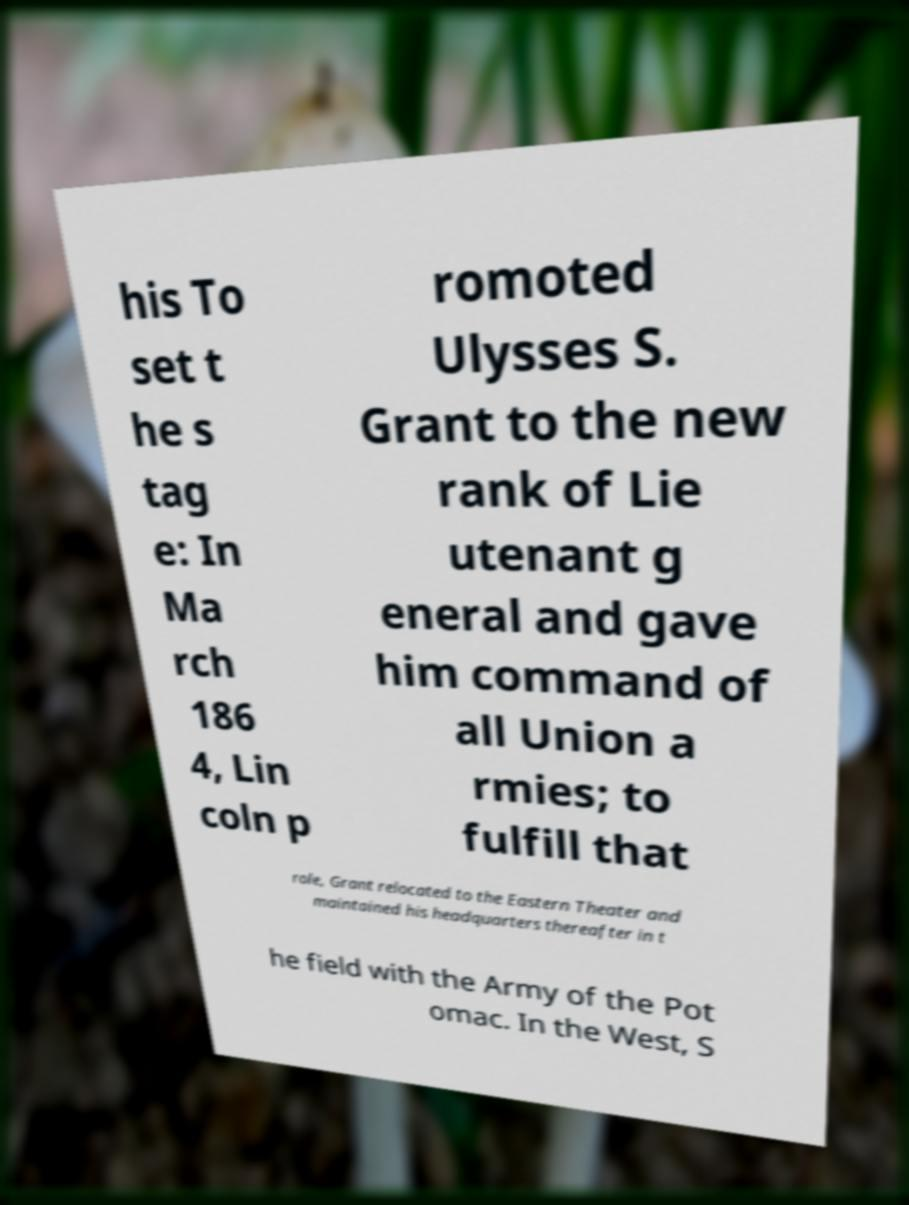Can you accurately transcribe the text from the provided image for me? his To set t he s tag e: In Ma rch 186 4, Lin coln p romoted Ulysses S. Grant to the new rank of Lie utenant g eneral and gave him command of all Union a rmies; to fulfill that role, Grant relocated to the Eastern Theater and maintained his headquarters thereafter in t he field with the Army of the Pot omac. In the West, S 